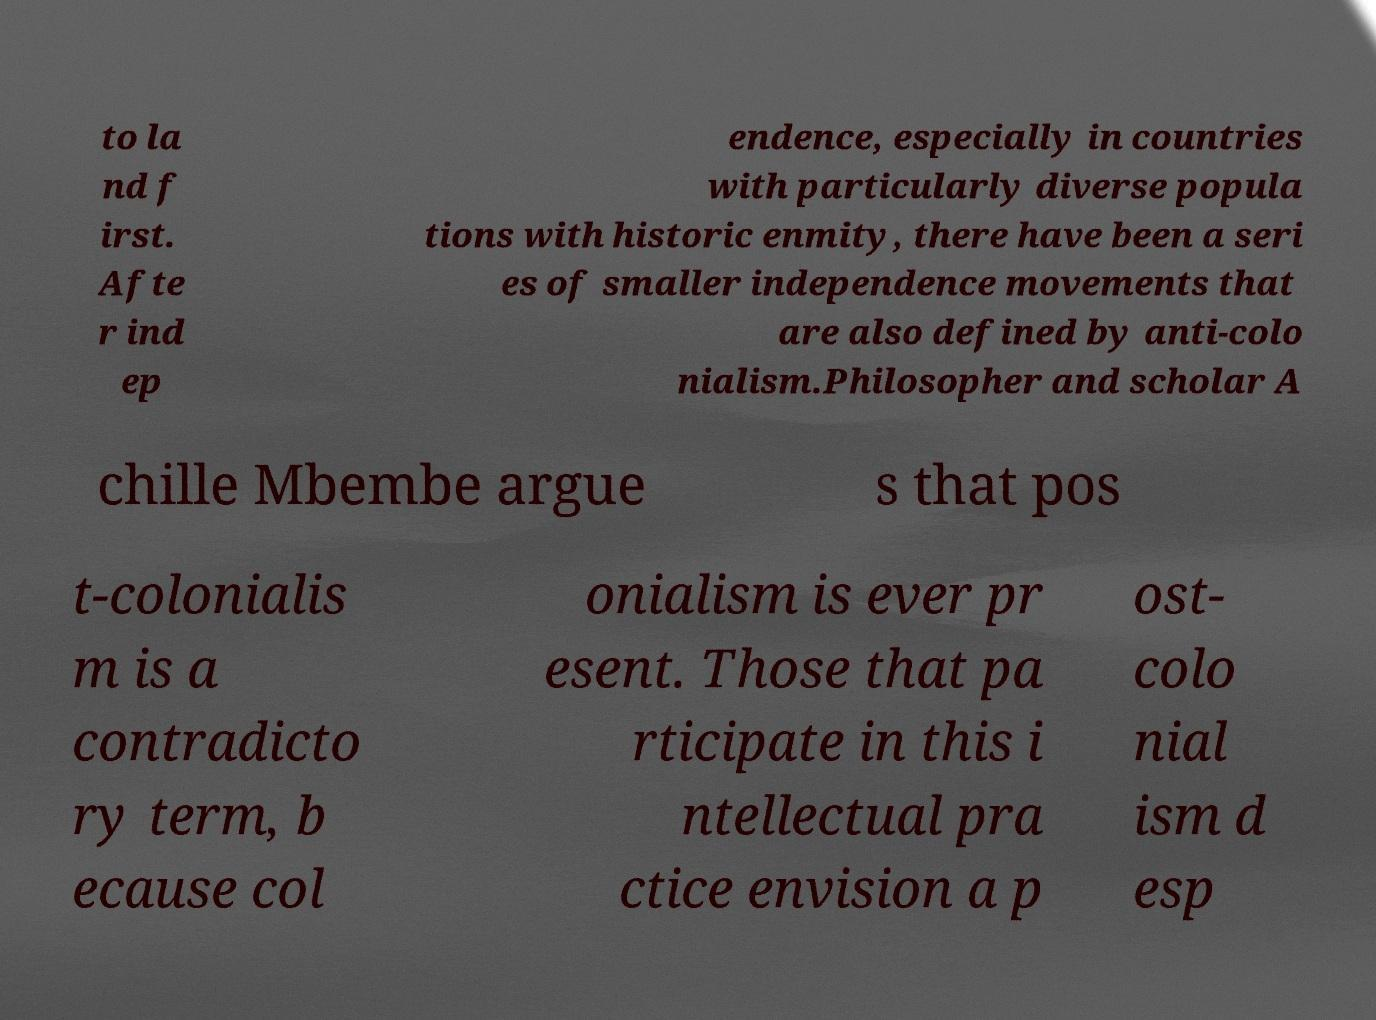Could you extract and type out the text from this image? to la nd f irst. Afte r ind ep endence, especially in countries with particularly diverse popula tions with historic enmity, there have been a seri es of smaller independence movements that are also defined by anti-colo nialism.Philosopher and scholar A chille Mbembe argue s that pos t-colonialis m is a contradicto ry term, b ecause col onialism is ever pr esent. Those that pa rticipate in this i ntellectual pra ctice envision a p ost- colo nial ism d esp 